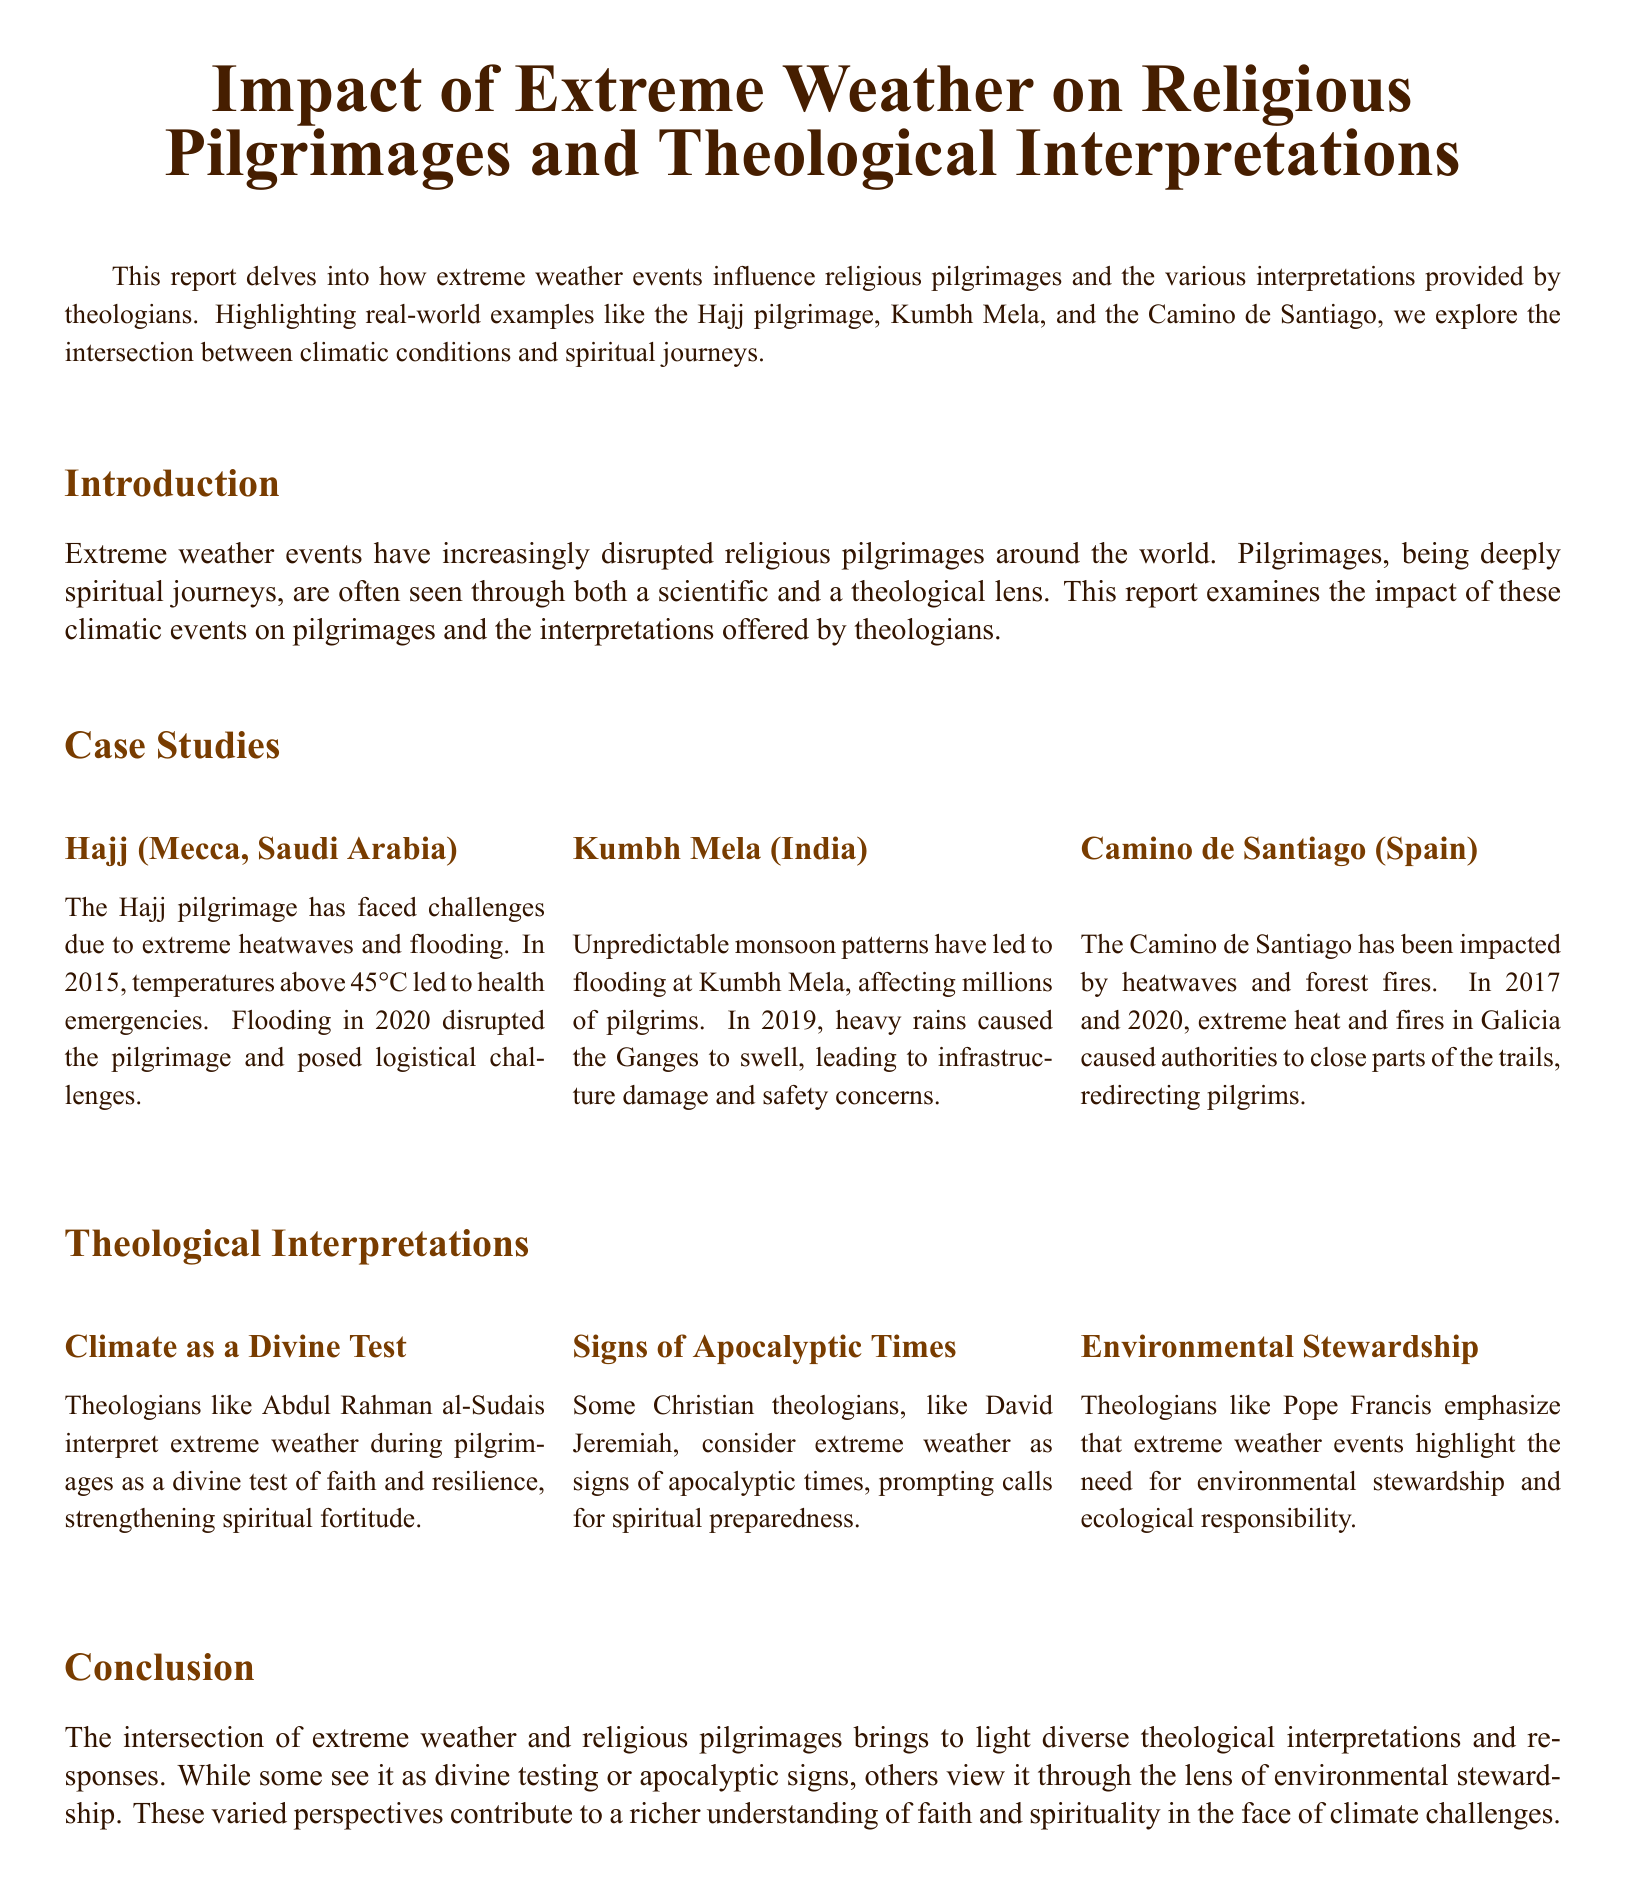what extreme weather event affected the Hajj in 2015? The report states that in 2015, temperatures above 45°C led to health emergencies during the Hajj pilgrimage.
Answer: temperatures above 45°C which religious pilgrimage experienced flooding due to unpredictable monsoon patterns? The Kumbh Mela is noted in the report as being affected by flooding due to unpredictable monsoon patterns.
Answer: Kumbh Mela who interprets extreme weather as a divine test of faith? The report mentions that theologian Abdul Rahman al-Sudais interprets extreme weather during pilgrimages as a divine test.
Answer: Abdul Rahman al-Sudais what significant environmental issues are highlighted by theologians regarding extreme weather? The report indicates that extreme weather events emphasize the need for environmental stewardship and ecological responsibility.
Answer: environmental stewardship how did extreme weather impact the Camino de Santiago in 2017? The report discusses extreme heat and forest fires causing authorities to close parts of the trails on the Camino de Santiago in 2017.
Answer: extreme heat and forest fires what theological perspective does David Jeremiah provide on extreme weather events? David Jeremiah considers extreme weather as signs of apocalyptic times which prompts calls for spiritual preparedness.
Answer: signs of apocalyptic times how many case studies are mentioned in the report? The report includes three case studies related to extreme weather and religious pilgrimages.
Answer: three what overarching theme does the conclusion of the report convey regarding faith? The conclusion highlights diverse theological interpretations and responses to extreme weather events in relation to faith and spirituality.
Answer: diverse theological interpretations 